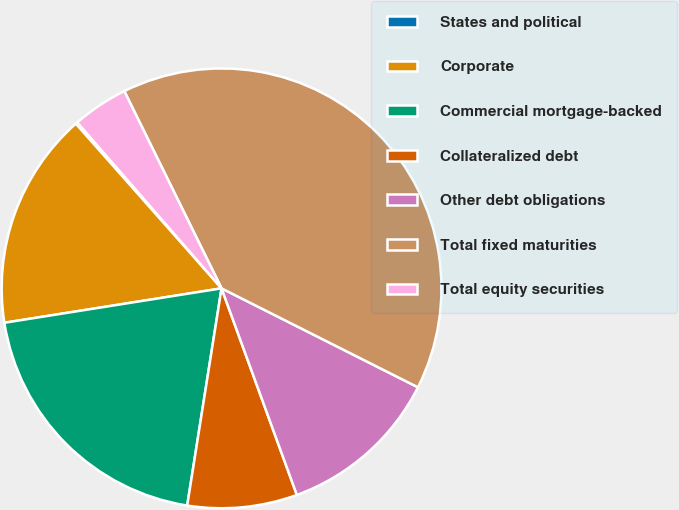<chart> <loc_0><loc_0><loc_500><loc_500><pie_chart><fcel>States and political<fcel>Corporate<fcel>Commercial mortgage-backed<fcel>Collateralized debt<fcel>Other debt obligations<fcel>Total fixed maturities<fcel>Total equity securities<nl><fcel>0.14%<fcel>15.97%<fcel>20.0%<fcel>8.06%<fcel>12.01%<fcel>39.72%<fcel>4.1%<nl></chart> 